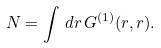Convert formula to latex. <formula><loc_0><loc_0><loc_500><loc_500>N = \int \, d { r } \, G ^ { ( 1 ) } ( { r } , { r } ) .</formula> 